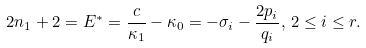<formula> <loc_0><loc_0><loc_500><loc_500>2 n _ { 1 } + 2 = E ^ { * } = \frac { c } { \kappa _ { 1 } } - \kappa _ { 0 } = - \sigma _ { i } - \frac { 2 p _ { i } } { q _ { i } } , \, 2 \leq i \leq r .</formula> 